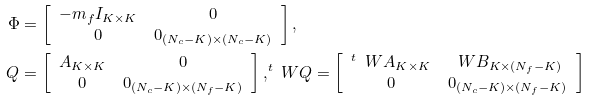Convert formula to latex. <formula><loc_0><loc_0><loc_500><loc_500>\Phi & = \left [ \begin{array} { c c } - m _ { f } I _ { K \times K } & 0 \\ 0 & 0 _ { ( N _ { c } - K ) \times ( N _ { c } - K ) } \end{array} \right ] , \\ Q & = \left [ \begin{array} { c c } A _ { K \times K } & 0 \\ 0 & 0 _ { ( N _ { c } - K ) \times ( N _ { f } - K ) } \end{array} \right ] , ^ { t } \ W Q = \left [ \begin{array} { c c } ^ { t } \, \ W A _ { K \times K } & \ W B _ { K \times ( N _ { f } - K ) } \\ 0 & 0 _ { ( N _ { c } - K ) \times ( N _ { f } - K ) } \end{array} \right ]</formula> 